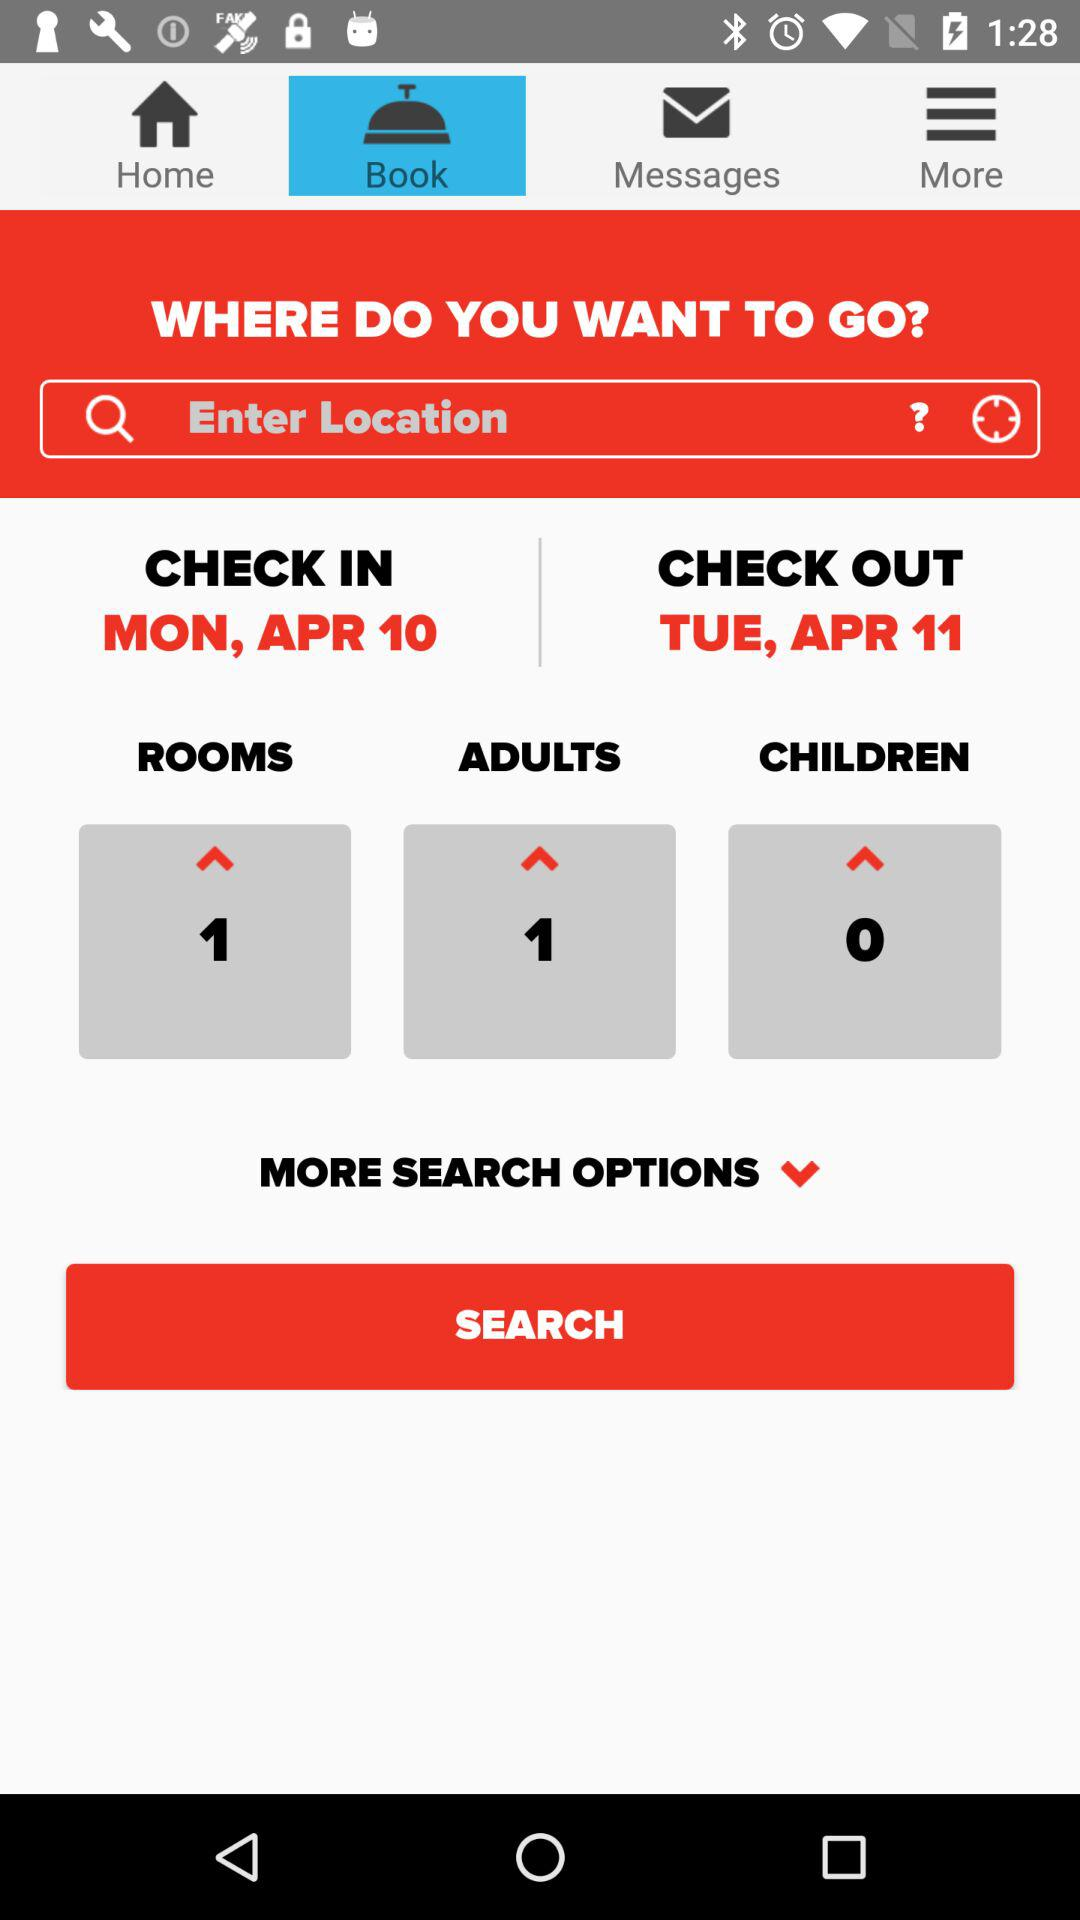How many rooms are selected for booking? There is 1 room selected for booking. 